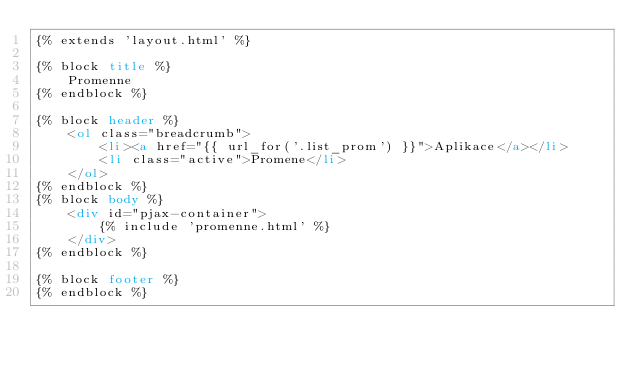Convert code to text. <code><loc_0><loc_0><loc_500><loc_500><_HTML_>{% extends 'layout.html' %}

{% block title %}
    Promenne
{% endblock %}

{% block header %}
    <ol class="breadcrumb">
        <li><a href="{{ url_for('.list_prom') }}">Aplikace</a></li>
        <li class="active">Promene</li>
    </ol>
{% endblock %}
{% block body %}
    <div id="pjax-container">
        {% include 'promenne.html' %}
    </div>
{% endblock %}

{% block footer %}
{% endblock %}
</code> 